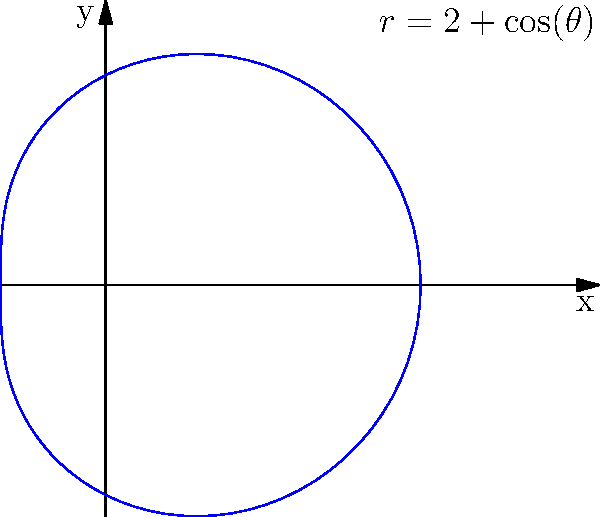As a writer drawing inspiration from rancher's experiences, you're researching the shape of horseshoes. Which polar equation best represents the shape of a typical horseshoe, as shown in the graph? To determine the polar equation that represents the shape of a horseshoe, let's analyze the graph:

1. The shape resembles a circle, but it's slightly offset from the origin and has a small indentation at the top.

2. The basic form of a circle in polar coordinates is $r = a$, where $a$ is the radius.

3. To create the offset, we need to add a constant to this equation. The graph shows that the minimum radius is about 1 unit, so we add 2 to our equation: $r = 2 + f(\theta)$

4. The indentation suggests a cosine function, as it creates a single "dip" in the shape over the full $2\pi$ range.

5. The amplitude of the cosine function appears to be 1 unit, as the shape varies between a radius of 1 and 3.

6. Combining these observations, we get the equation $r = 2 + \cos(\theta)$

7. This equation creates a circle-like shape with a radius that varies between 1 and 3, centered at (1, 0) in Cartesian coordinates, which matches the graph.

Therefore, the polar equation that best represents the shape of a typical horseshoe is $r = 2 + \cos(\theta)$.
Answer: $r = 2 + \cos(\theta)$ 